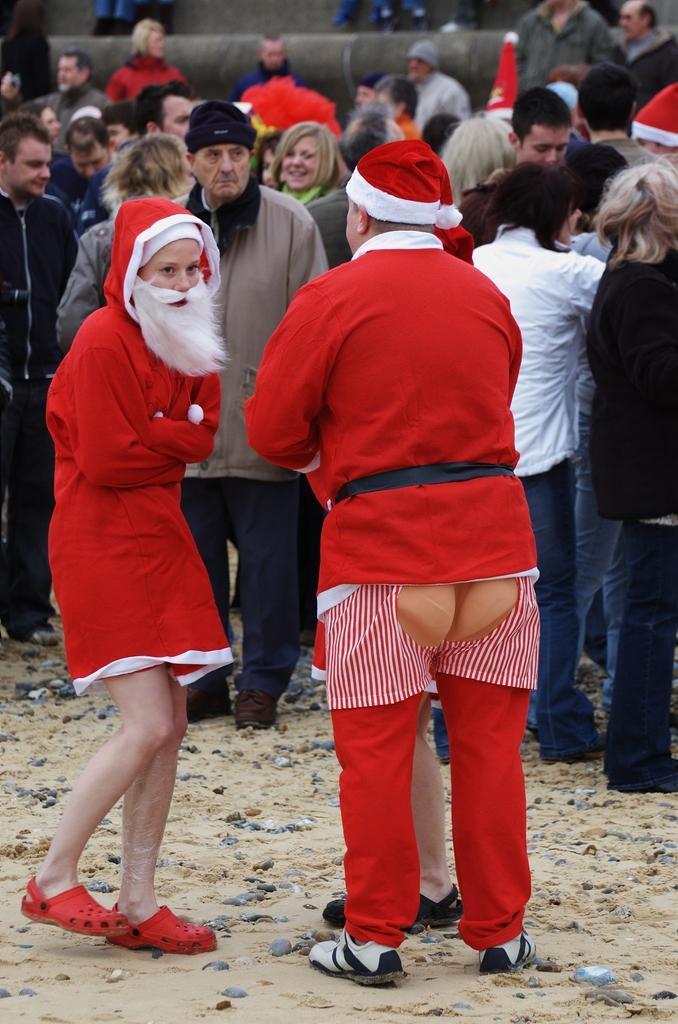In one or two sentences, can you explain what this image depicts? In this image I can see three persons in santa claus dresses. In the background there are group of people and few of them are wearing santa claus hats. 